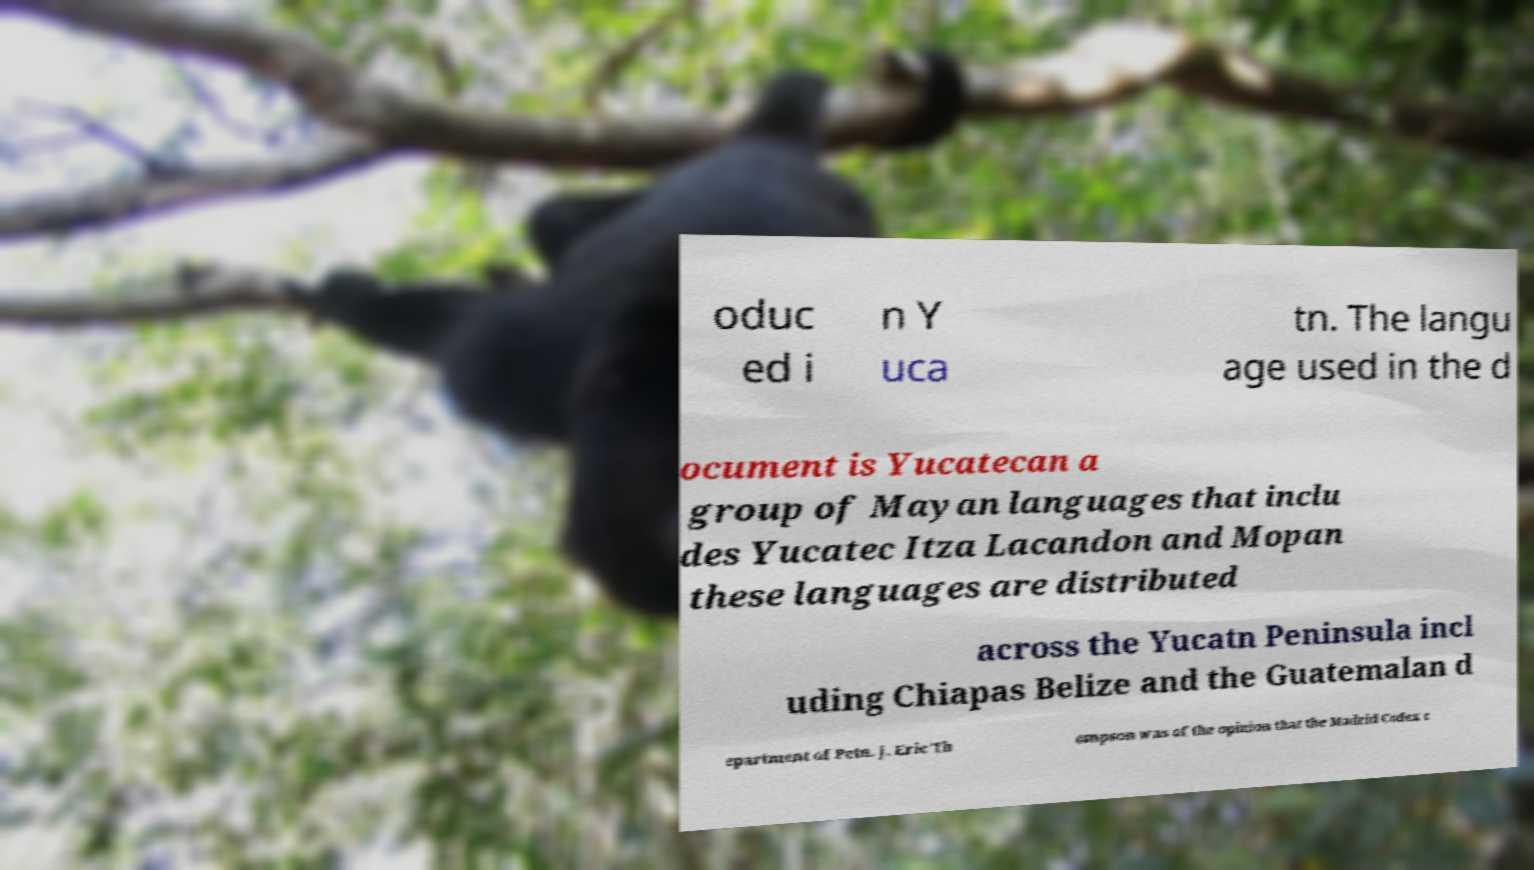Please read and relay the text visible in this image. What does it say? oduc ed i n Y uca tn. The langu age used in the d ocument is Yucatecan a group of Mayan languages that inclu des Yucatec Itza Lacandon and Mopan these languages are distributed across the Yucatn Peninsula incl uding Chiapas Belize and the Guatemalan d epartment of Petn. J. Eric Th ompson was of the opinion that the Madrid Codex c 